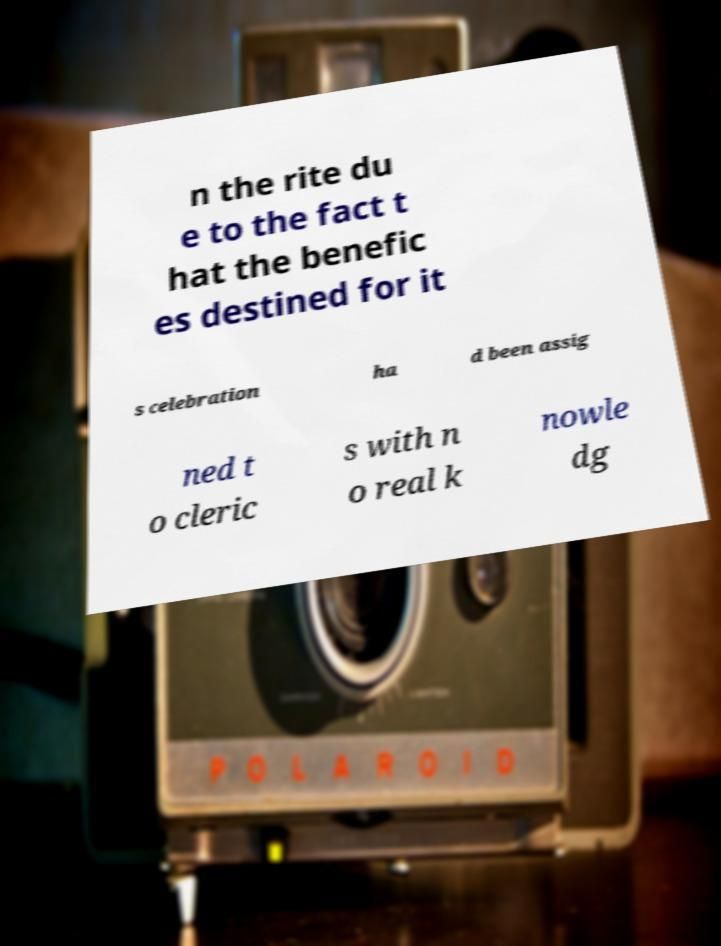Please read and relay the text visible in this image. What does it say? n the rite du e to the fact t hat the benefic es destined for it s celebration ha d been assig ned t o cleric s with n o real k nowle dg 